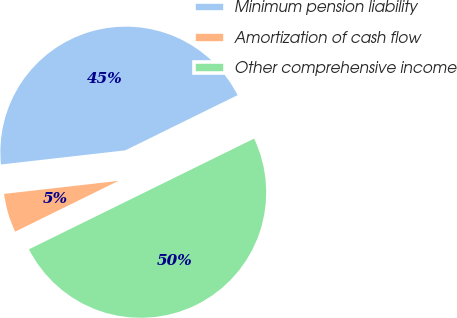Convert chart to OTSL. <chart><loc_0><loc_0><loc_500><loc_500><pie_chart><fcel>Minimum pension liability<fcel>Amortization of cash flow<fcel>Other comprehensive income<nl><fcel>44.53%<fcel>5.47%<fcel>50.0%<nl></chart> 